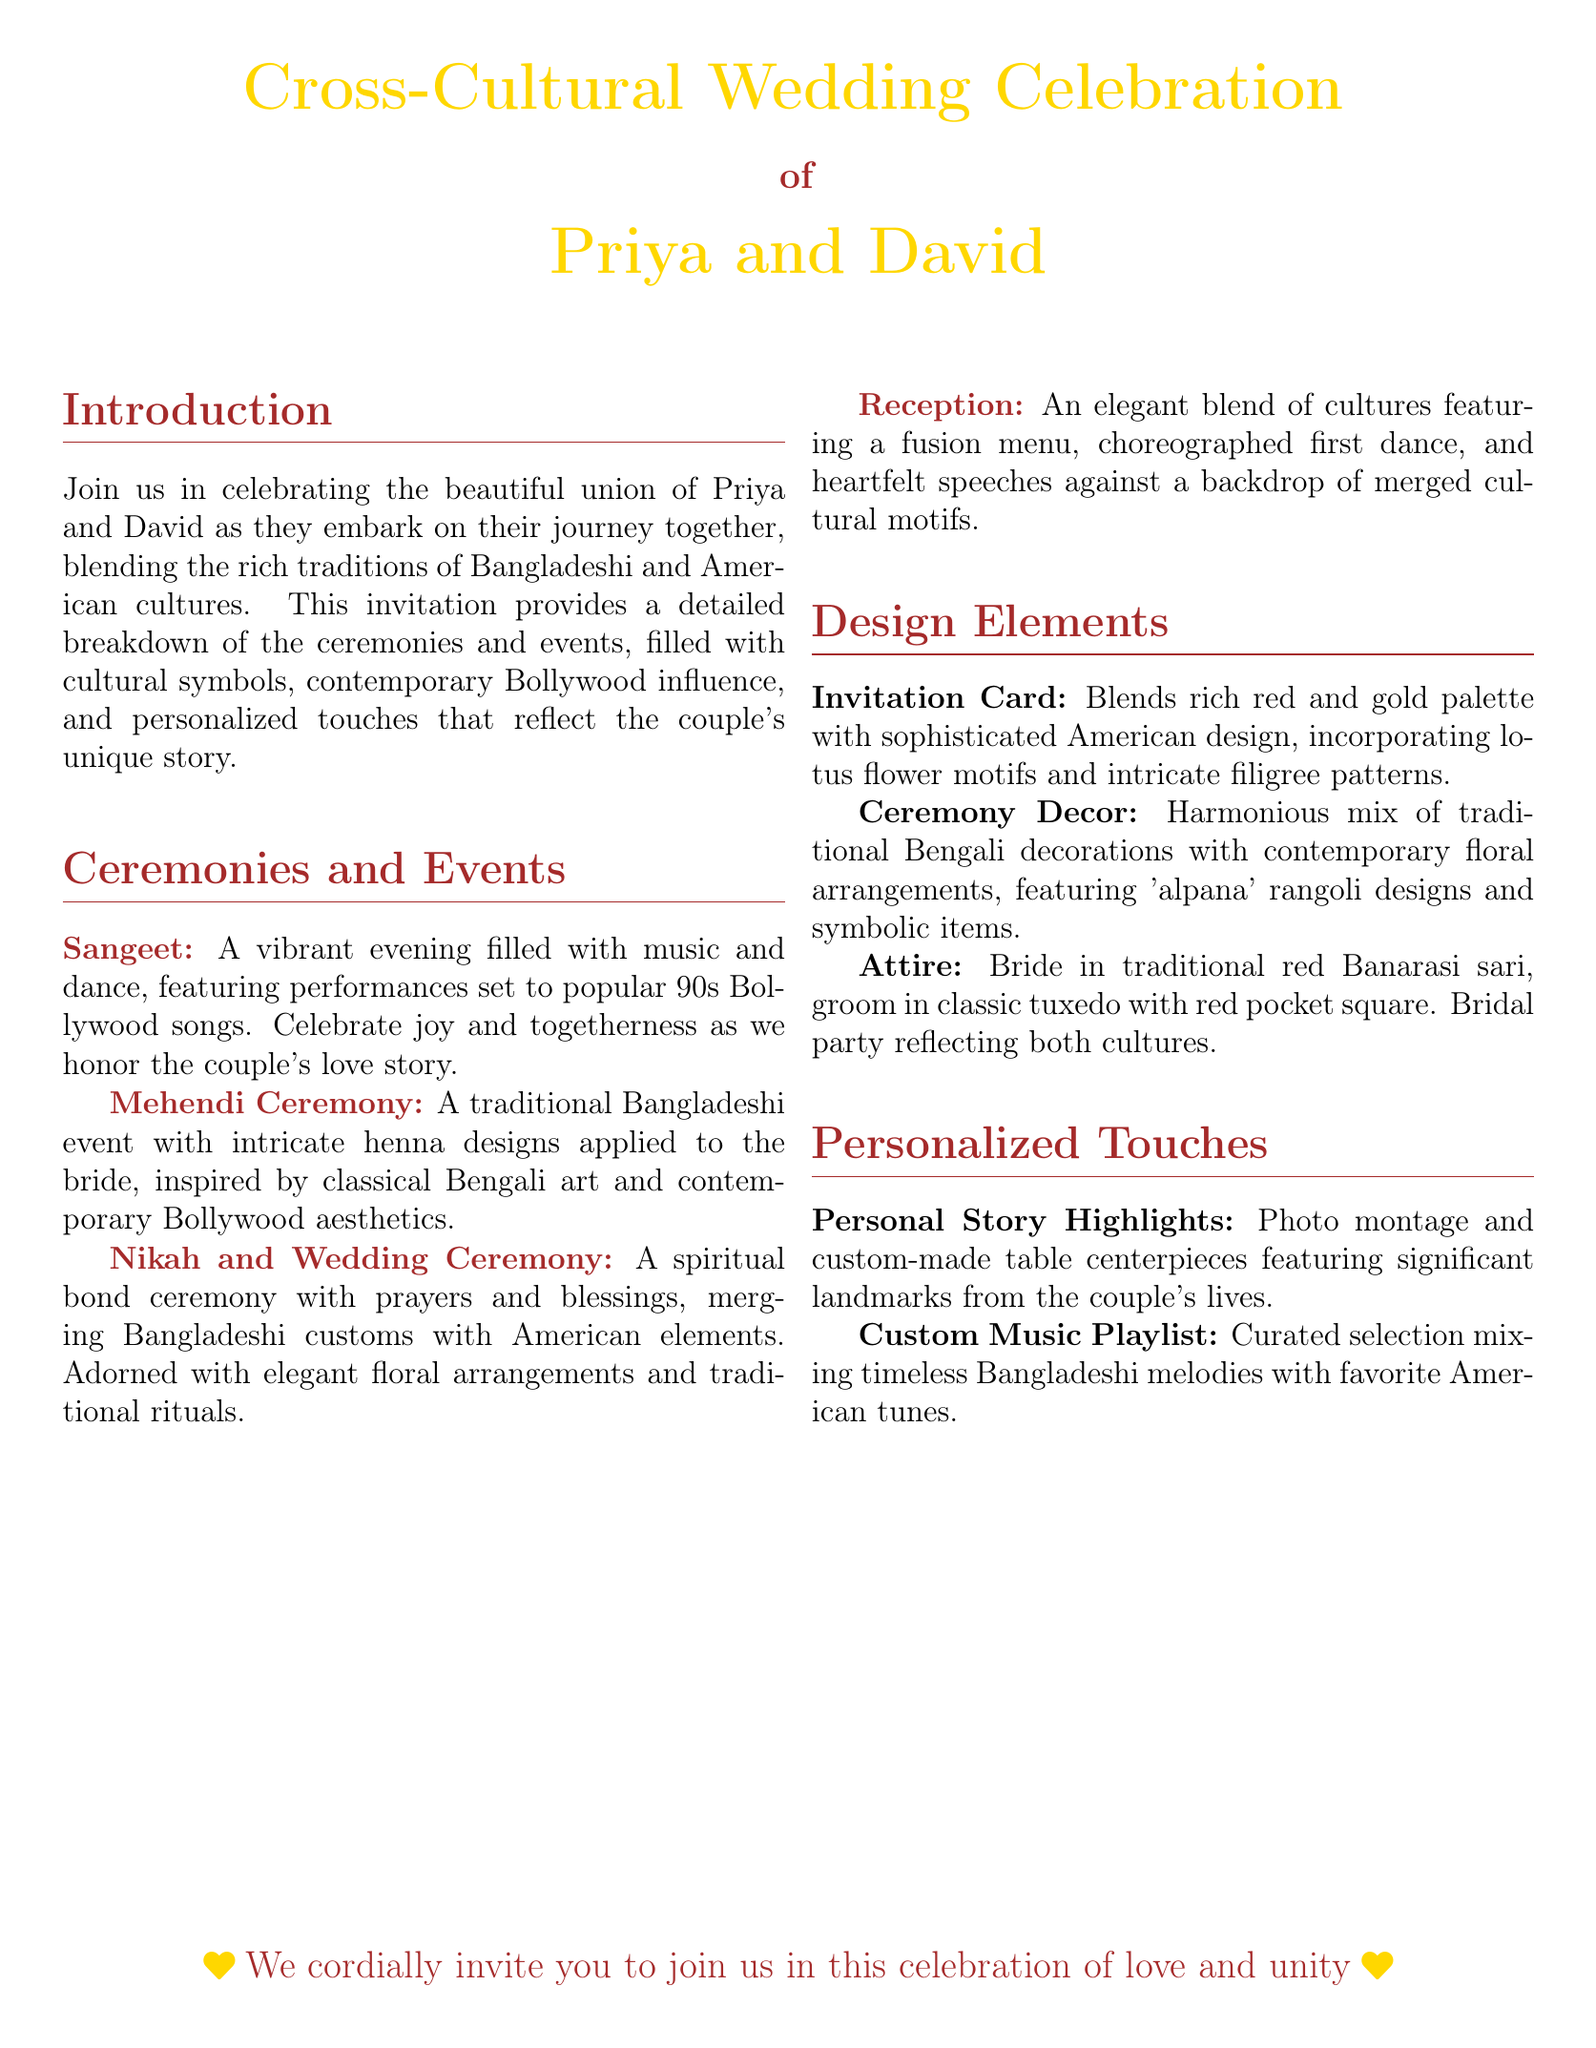What is the name of the couple getting married? The names of the couple are mentioned prominently in the document's title section.
Answer: Priya and David What color palette is featured in the invitation card? The details about the invitation card's design theme, including color palette, are outlined in the design elements section.
Answer: Red and gold What ceremony features performances to 90s Bollywood songs? The document specifies which event involves music and dance performances centered around Broadway hits.
Answer: Sangeet What tradition is highlighted in the Mehendi Ceremony? The details about the Mehendi Ceremony mention the type of art that inspires the henna designs.
Answer: Classical Bengali art What type of attire does the bride wear? The attire section specifies the kind of garment the bride is adorned in for the ceremony.
Answer: Red Banarasi sari What is included in the personalized touches? The personalized touches section summarizes the features that reflect the couple's journey together.
Answer: Photo montage What type of menu will be featured at the reception? The document outlines the dining experience occurring at the reception, providing details about the food served.
Answer: Fusion menu What symbol is featured prominently in the invitation card design? A specific cultural motif is highlighted in the invitation card's design description.
Answer: Lotus flower What type of music is included in the custom playlist? The custom music playlist section describes the nature of the songs mixed together for the celebration.
Answer: Timeless Bangladeshi melodies with favorite American tunes 